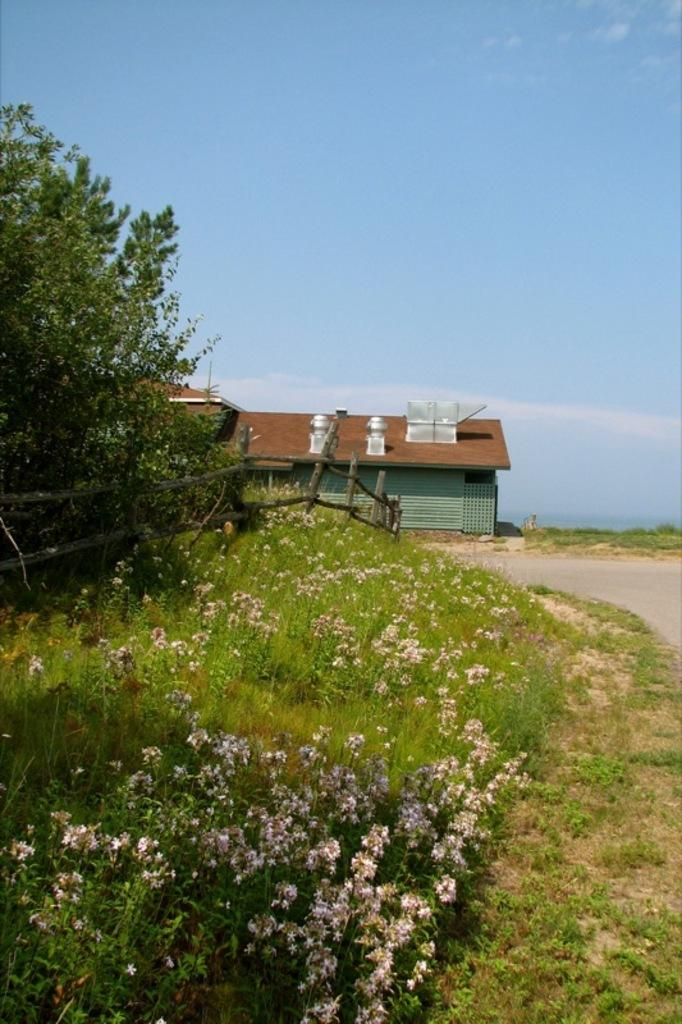What color are the flowers in the image? The flowers in the image are white in color. What other types of vegetation can be seen in the image? There are plants and trees in the image. What color are the plants and trees? The plants and trees are green in color. What structure is visible in the background of the image? There is a house in the background of the image. What color is the sky in the image? The sky is blue in color. Can you see a cushion on the tree in the image? There is no cushion present on the tree in the image. Is there a dog playing with the flowers in the image? There is no dog present in the image; it only features flowers, plants, trees, a house, and the sky. 